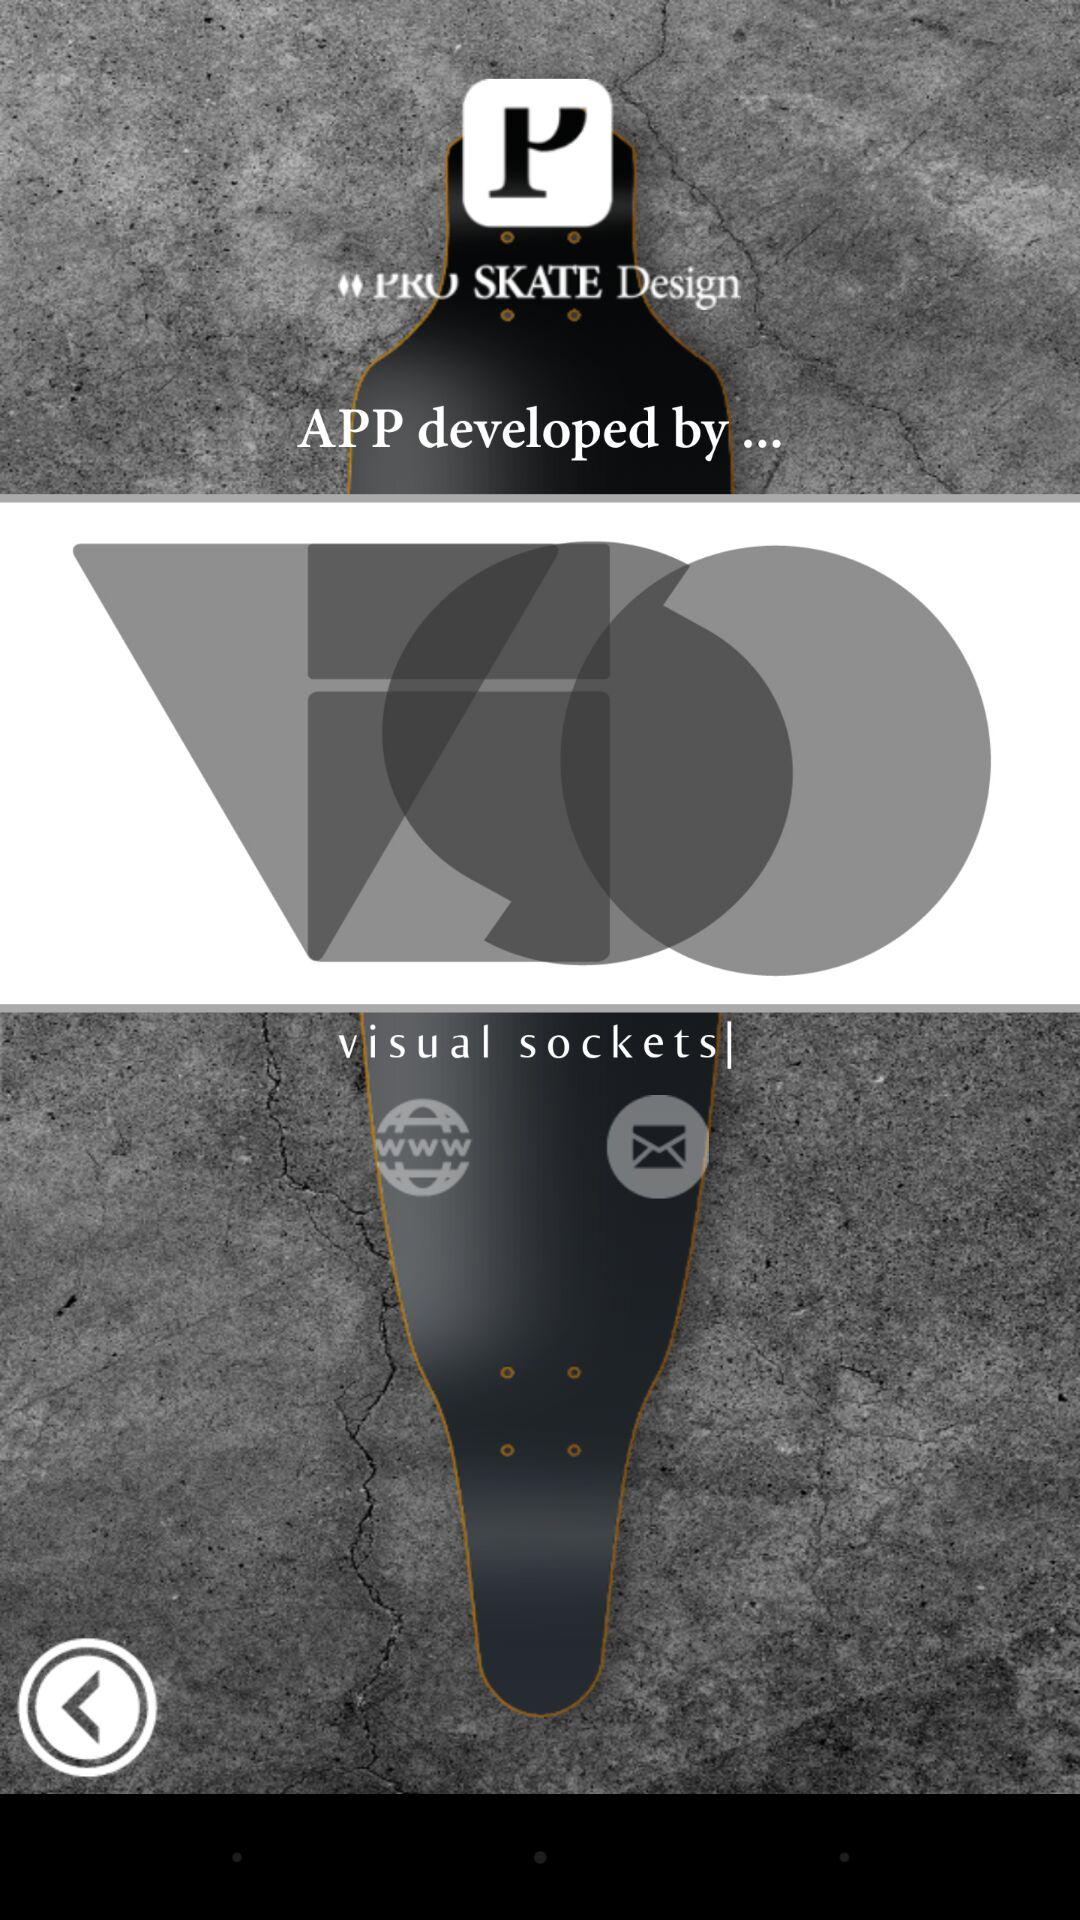What is the name of the application? The name of the application is "PRO SKATE Design". 